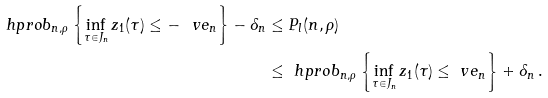Convert formula to latex. <formula><loc_0><loc_0><loc_500><loc_500>\ h p r o b _ { n , \rho } \left \{ \inf _ { \tau \in J _ { n } } z _ { 1 } ( \tau ) \leq - \ v e _ { n } \right \} - \delta _ { n } & \leq P _ { l } ( n , \rho ) \\ & \leq \ h p r o b _ { n , \rho } \left \{ \inf _ { \tau \in J _ { n } } z _ { 1 } ( \tau ) \leq \ v e _ { n } \right \} + \delta _ { n } \, .</formula> 